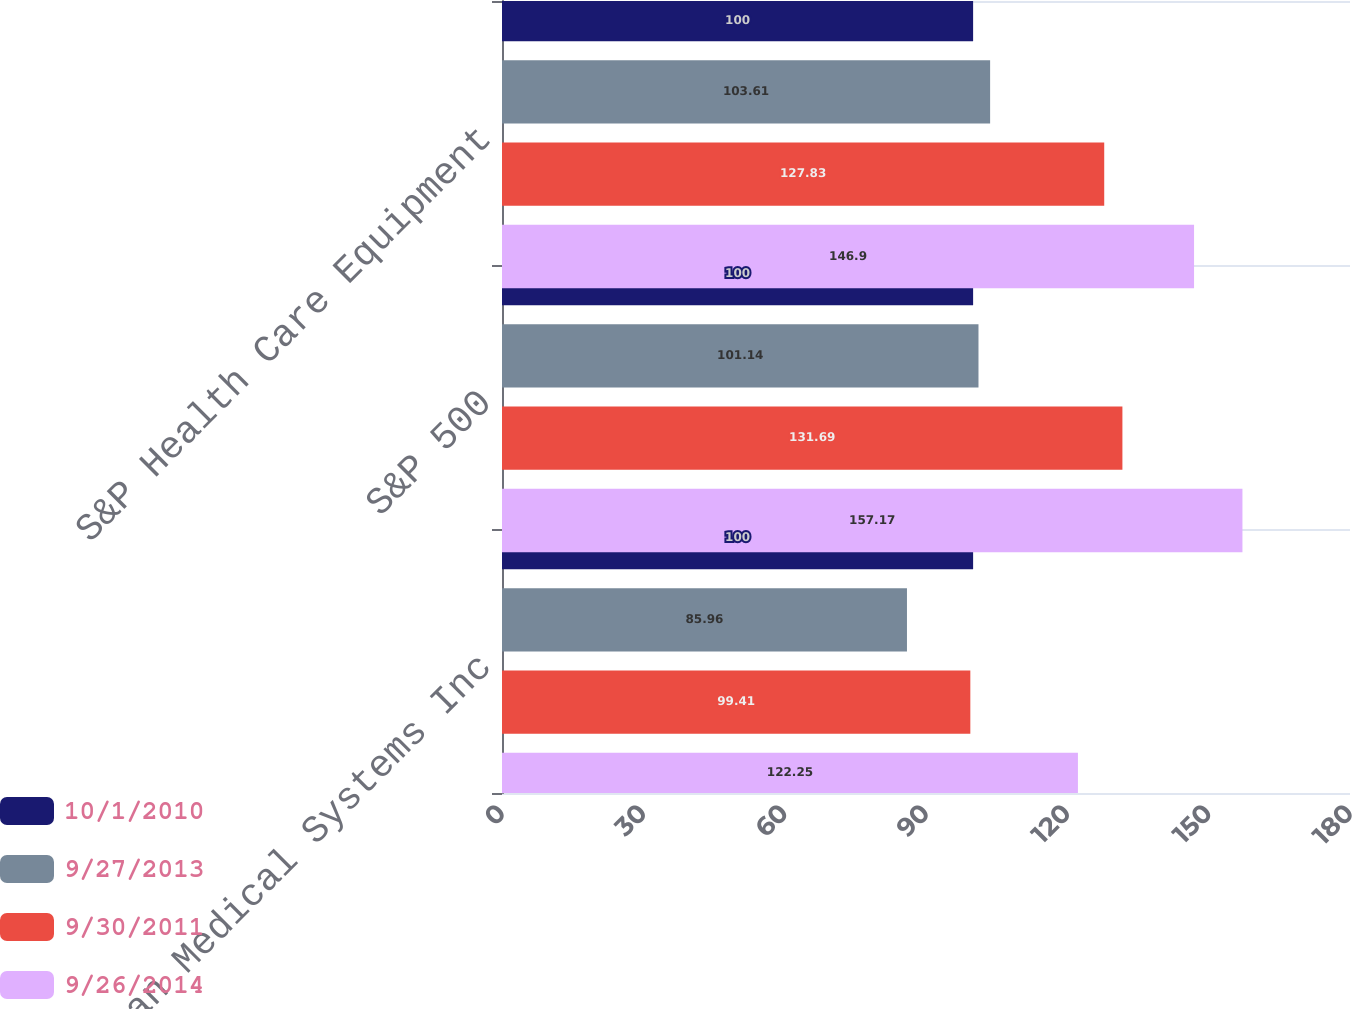Convert chart. <chart><loc_0><loc_0><loc_500><loc_500><stacked_bar_chart><ecel><fcel>Varian Medical Systems Inc<fcel>S&P 500<fcel>S&P Health Care Equipment<nl><fcel>10/1/2010<fcel>100<fcel>100<fcel>100<nl><fcel>9/27/2013<fcel>85.96<fcel>101.14<fcel>103.61<nl><fcel>9/30/2011<fcel>99.41<fcel>131.69<fcel>127.83<nl><fcel>9/26/2014<fcel>122.25<fcel>157.17<fcel>146.9<nl></chart> 